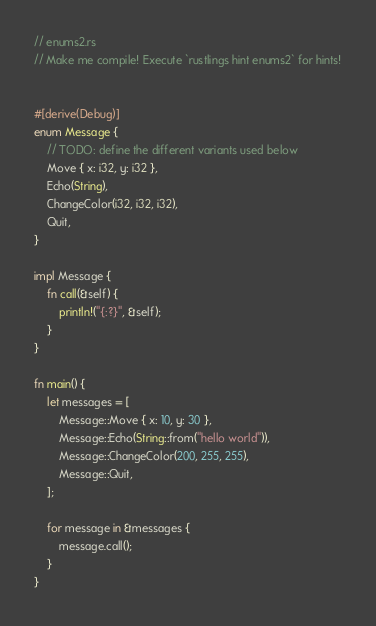<code> <loc_0><loc_0><loc_500><loc_500><_Rust_>// enums2.rs
// Make me compile! Execute `rustlings hint enums2` for hints!


#[derive(Debug)]
enum Message {
    // TODO: define the different variants used below
    Move { x: i32, y: i32 },
    Echo(String),
    ChangeColor(i32, i32, i32),
    Quit,
}

impl Message {
    fn call(&self) {
        println!("{:?}", &self);
    }
}

fn main() {
    let messages = [
        Message::Move { x: 10, y: 30 },
        Message::Echo(String::from("hello world")),
        Message::ChangeColor(200, 255, 255),
        Message::Quit,
    ];

    for message in &messages {
        message.call();
    }
}
</code> 